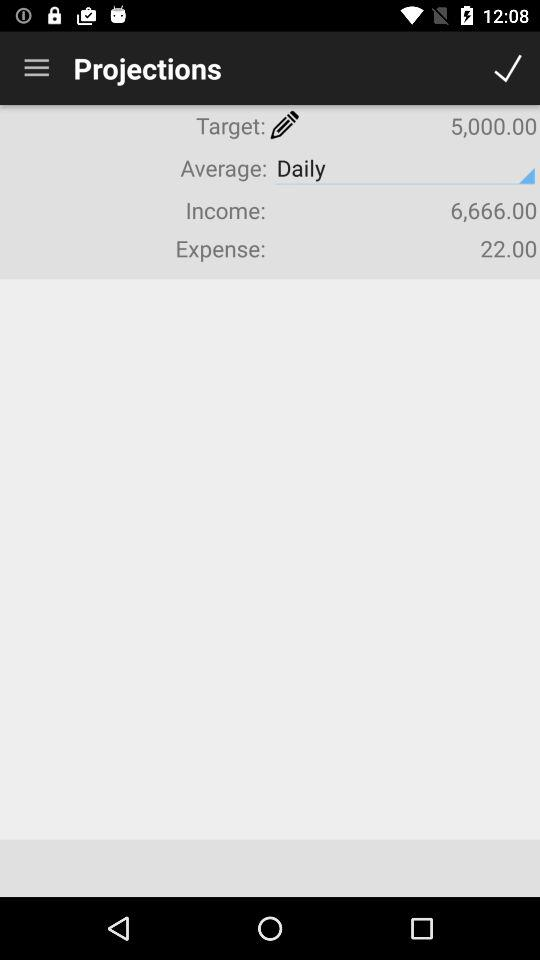How much is the expense? The expense is "22.00". 